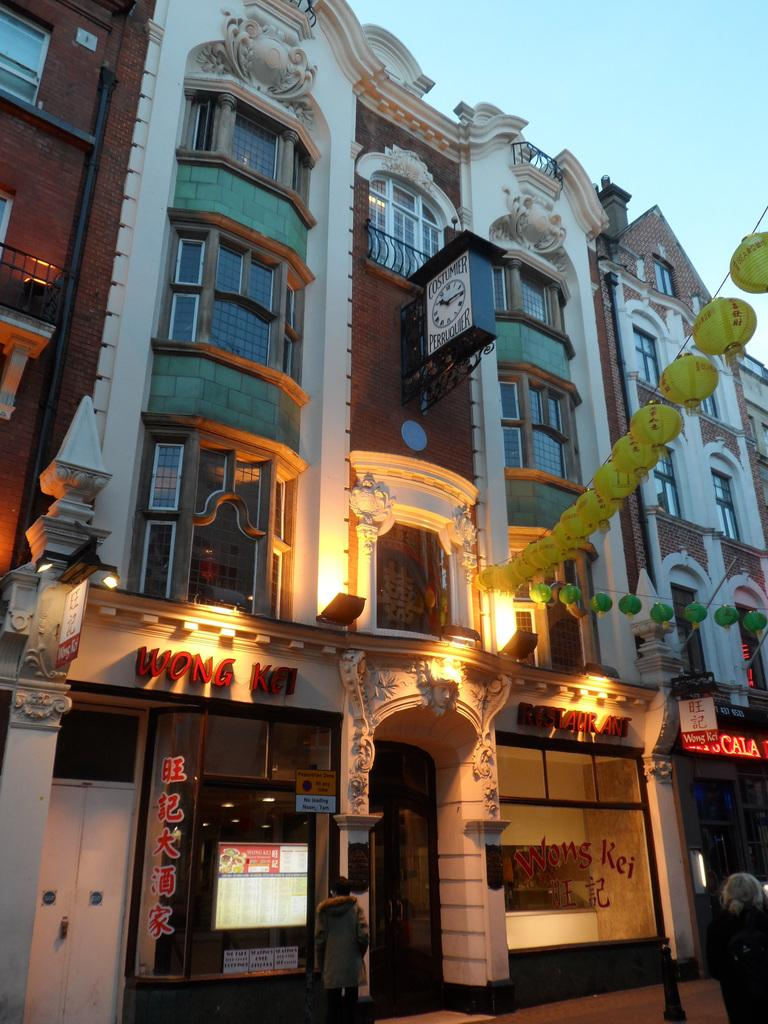What type of structures can be seen in the image? There are buildings in the image. What can be observed illuminating the scene in the image? Lights are visible in the image. What type of lighting fixtures are present in the image? Lanterns are present in the image. What time-related information can be found in the image? There is a clock board in the image. What part of the natural environment is visible in the image? The sky is visible in the image. Are there any human figures in the image? Yes, people are present in the image. What type of surface can be seen in the image that people might walk on? There is a path in the image. What type of dress is the zephyr wearing in the image? There is no zephyr or dress present in the image. What feeling does the image evoke in the viewer? The image itself does not evoke a specific feeling, as feelings are subjective and vary from person to person. 